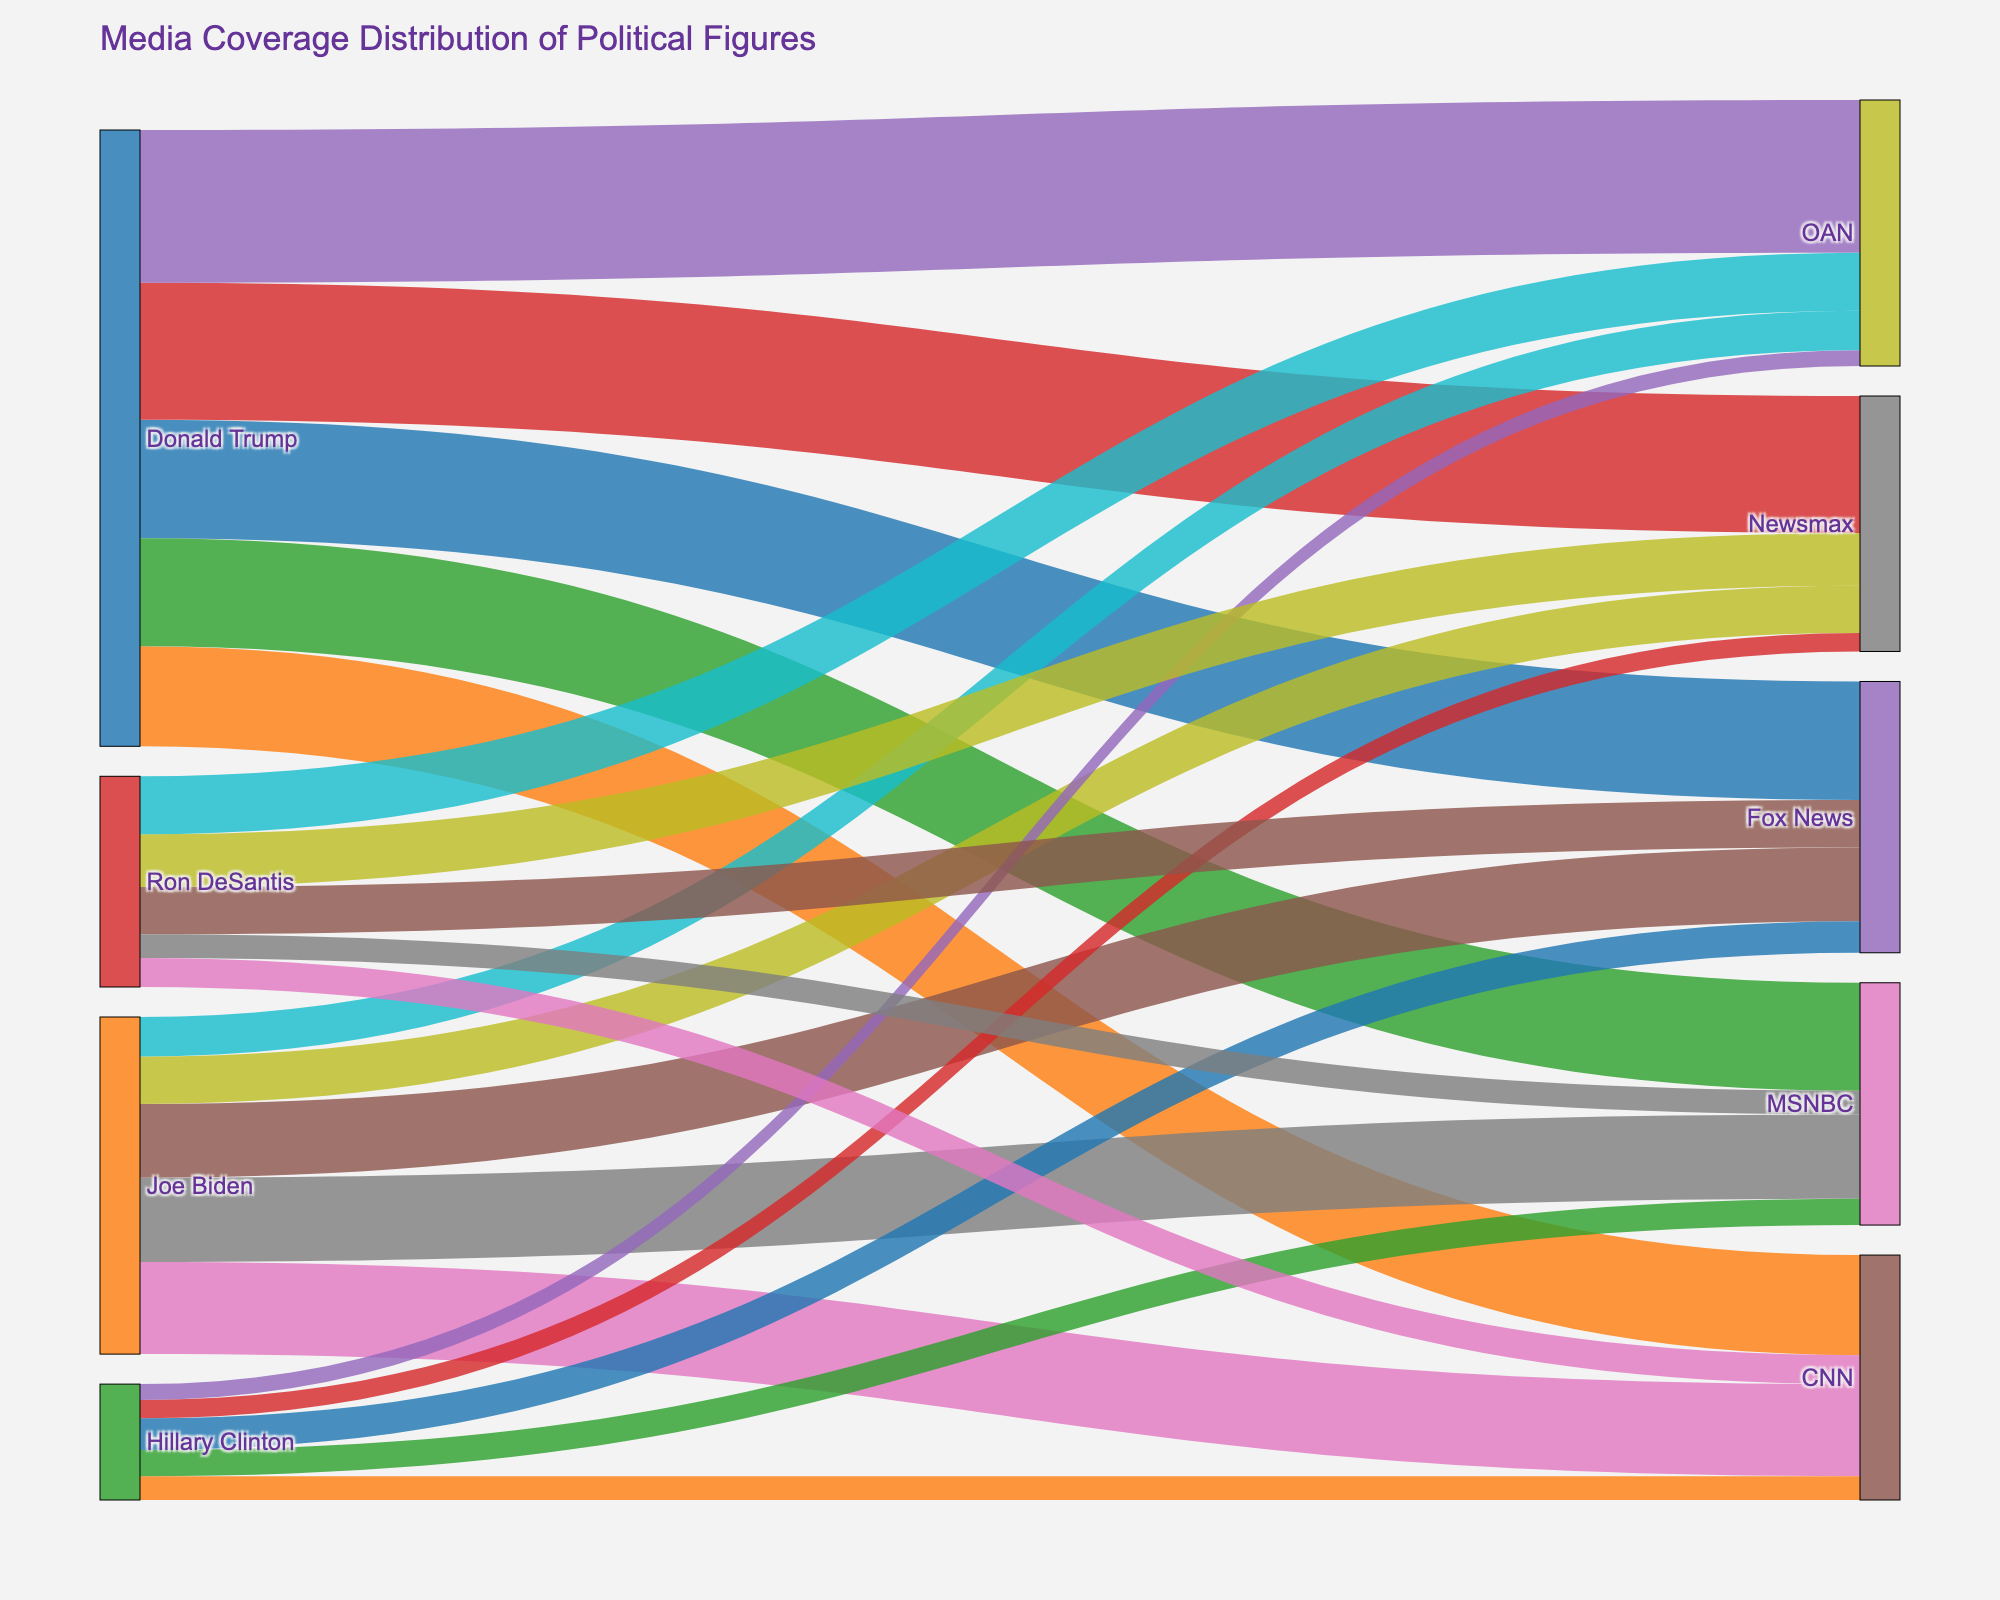What is the title of the figure? The title of the figure is usually displayed at the top of the plot. Here, the title summarizes the content of the Sankey Diagram.
Answer: Media Coverage Distribution of Political Figures Which network provides the highest media coverage for Donald Trump? To answer this question, look for the link with the highest value connecting Donald Trump to the networks.
Answer: OAN How many hours of media coverage does Fox News provide to Joe Biden? Find the link connecting Joe Biden and Fox News and read the value associated with it.
Answer: 280 hours What is the total amount of media coverage given to Hillary Clinton across all networks? To find this, sum the coverage hours for Hillary Clinton across all listed networks: 120 (Fox News) + 90 (CNN) + 100 (MSNBC) + 70 (Newsmax) + 60 (OAN).
Answer: 440 hours Which political figure receives the least coverage from MSNBC? Compare the coverage hours provided by MSNBC to Donald Trump, Joe Biden, Hillary Clinton, and Ron DeSantis. The smallest value indicates the least coverage.
Answer: Ron DeSantis Which political figure receives the most media coverage overall? Sum the coverage hours for each political figure across all networks. Donald Trump: 450 + 380 + 410 + 520 + 580. Joe Biden: 280 + 350 + 320 + 180 + 150. Hillary Clinton: 120 + 90 + 100 + 70 + 60. Ron DeSantis: 180 + 110 + 90 + 200 + 220. Compare the total sums.
Answer: Donald Trump How does the media coverage of Ron DeSantis on Newsmax compare with that on OAN? Examine the coverage hours for Ron DeSantis on Newsmax and OAN. Note the respective hours and determine the difference.
Answer: OAN covers 20 hours more than Newsmax Calculate the average media coverage per network for Joe Biden. Sum up Joe Biden's media coverage hours across all networks and divide by the number of networks: (280 + 350 + 320 + 180 + 150) / 5.
Answer: 256 hours Compare the total media coverage hours of OAN for Donald Trump and Joe Biden. Sum up the hours provided by OAN for Donald Trump and Joe Biden and compare: Donald Trump (580) vs Joe Biden (150).
Answer: Donald Trump gets significantly more coverage Which news network provides the most balanced coverage across all political figures? Calculate the standard deviation of each network's coverage hours across all political figures. The network with the smallest standard deviation offers the most balanced coverage. This requires examining each network's variance across the listed figures.
Answer: CNN 